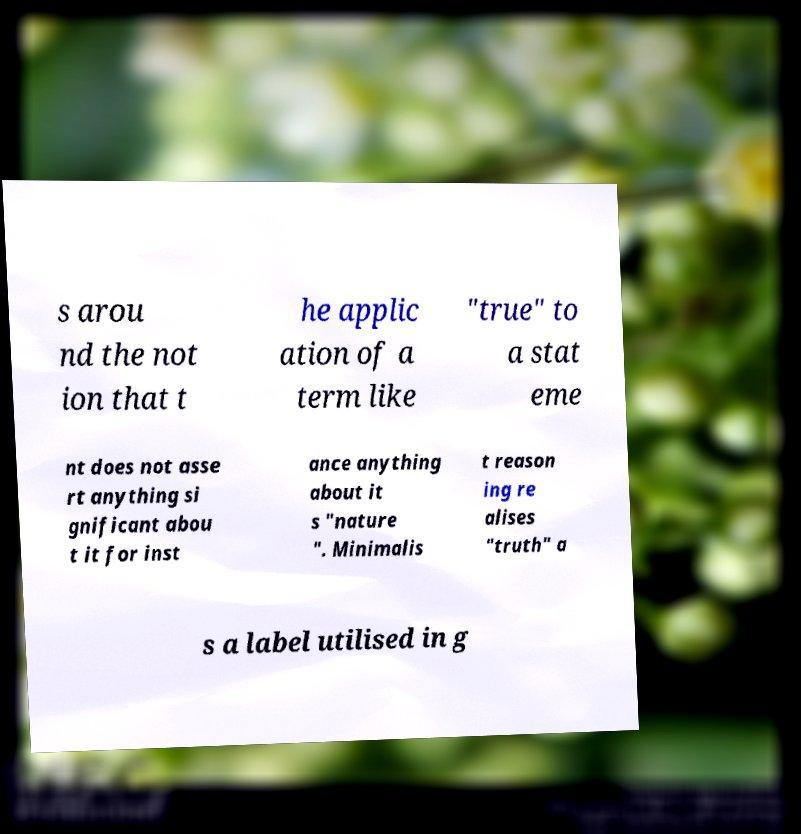I need the written content from this picture converted into text. Can you do that? s arou nd the not ion that t he applic ation of a term like "true" to a stat eme nt does not asse rt anything si gnificant abou t it for inst ance anything about it s "nature ". Minimalis t reason ing re alises "truth" a s a label utilised in g 